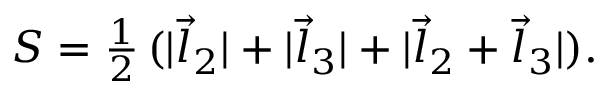<formula> <loc_0><loc_0><loc_500><loc_500>S = { \frac { 1 } { 2 } } \, ( | \vec { l } _ { 2 } | + | \vec { l } _ { 3 } | + | \vec { l } _ { 2 } + \vec { l } _ { 3 } | ) .</formula> 